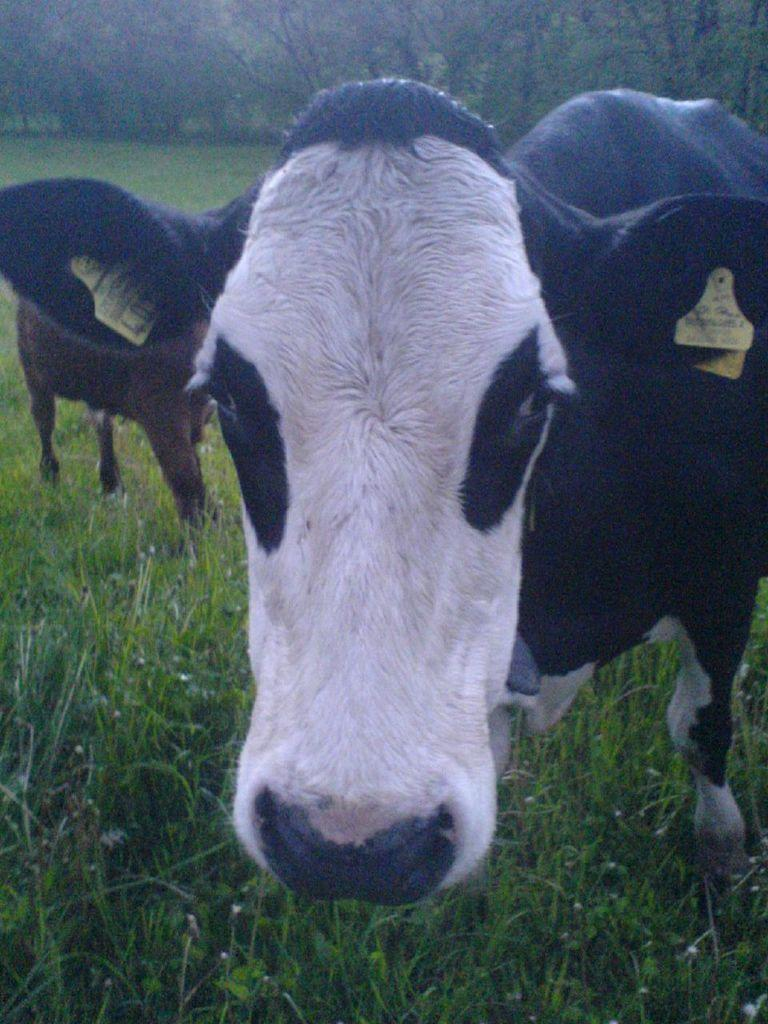What type of vegetation is at the bottom of the image? There is grass at the bottom of the image. What can be seen in the middle of the image? There are animals in the middle of the image. What is visible in the background of the image? There are trees in the background of the image. What type of cord is being used by the animals in the image? There is no cord present in the image; the animals are not using any tools or accessories. How does the image stop the animals from moving? The image is a static representation and does not have the ability to stop or control the animals' movements. 